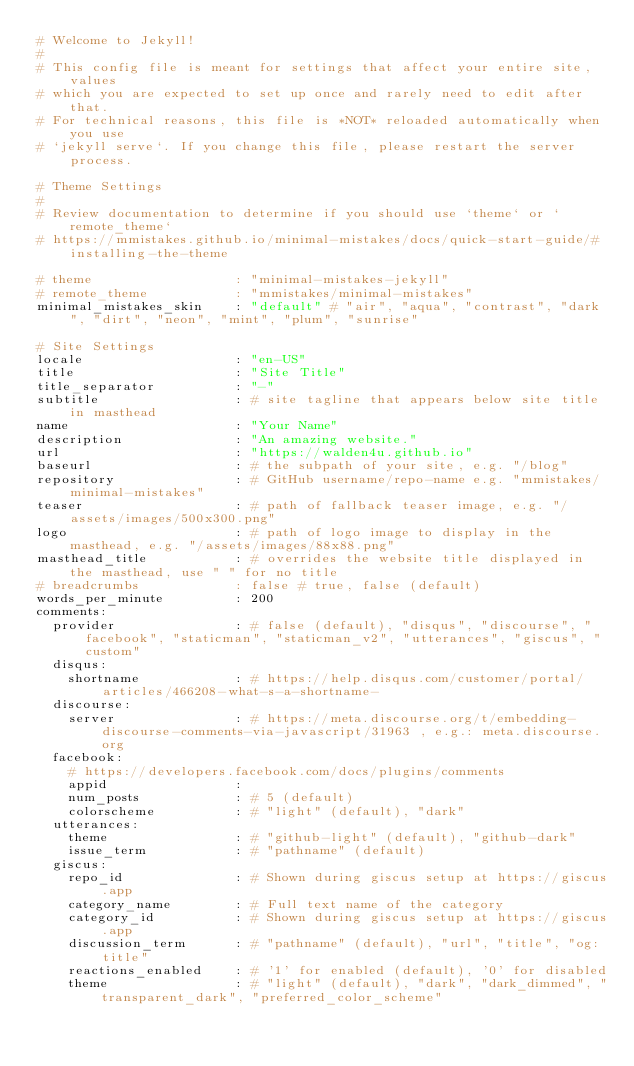Convert code to text. <code><loc_0><loc_0><loc_500><loc_500><_YAML_># Welcome to Jekyll!
#
# This config file is meant for settings that affect your entire site, values
# which you are expected to set up once and rarely need to edit after that.
# For technical reasons, this file is *NOT* reloaded automatically when you use
# `jekyll serve`. If you change this file, please restart the server process.

# Theme Settings
#
# Review documentation to determine if you should use `theme` or `remote_theme`
# https://mmistakes.github.io/minimal-mistakes/docs/quick-start-guide/#installing-the-theme

# theme                  : "minimal-mistakes-jekyll"
# remote_theme           : "mmistakes/minimal-mistakes"
minimal_mistakes_skin    : "default" # "air", "aqua", "contrast", "dark", "dirt", "neon", "mint", "plum", "sunrise"

# Site Settings
locale                   : "en-US"
title                    : "Site Title"
title_separator          : "-"
subtitle                 : # site tagline that appears below site title in masthead
name                     : "Your Name"
description              : "An amazing website."
url                      : "https://walden4u.github.io"
baseurl                  : # the subpath of your site, e.g. "/blog"
repository               : # GitHub username/repo-name e.g. "mmistakes/minimal-mistakes"
teaser                   : # path of fallback teaser image, e.g. "/assets/images/500x300.png"
logo                     : # path of logo image to display in the masthead, e.g. "/assets/images/88x88.png"
masthead_title           : # overrides the website title displayed in the masthead, use " " for no title
# breadcrumbs            : false # true, false (default)
words_per_minute         : 200
comments:
  provider               : # false (default), "disqus", "discourse", "facebook", "staticman", "staticman_v2", "utterances", "giscus", "custom"
  disqus:
    shortname            : # https://help.disqus.com/customer/portal/articles/466208-what-s-a-shortname-
  discourse:
    server               : # https://meta.discourse.org/t/embedding-discourse-comments-via-javascript/31963 , e.g.: meta.discourse.org
  facebook:
    # https://developers.facebook.com/docs/plugins/comments
    appid                :
    num_posts            : # 5 (default)
    colorscheme          : # "light" (default), "dark"
  utterances:
    theme                : # "github-light" (default), "github-dark"
    issue_term           : # "pathname" (default)
  giscus:
    repo_id              : # Shown during giscus setup at https://giscus.app
    category_name        : # Full text name of the category
    category_id          : # Shown during giscus setup at https://giscus.app
    discussion_term      : # "pathname" (default), "url", "title", "og:title"
    reactions_enabled    : # '1' for enabled (default), '0' for disabled
    theme                : # "light" (default), "dark", "dark_dimmed", "transparent_dark", "preferred_color_scheme"</code> 